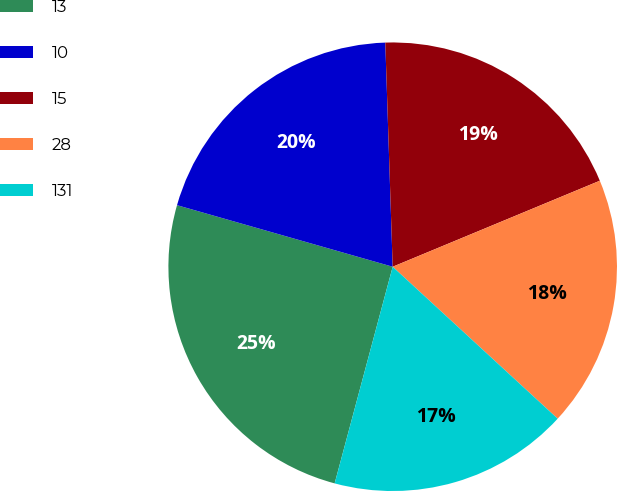Convert chart. <chart><loc_0><loc_0><loc_500><loc_500><pie_chart><fcel>13<fcel>10<fcel>15<fcel>28<fcel>131<nl><fcel>25.26%<fcel>20.05%<fcel>19.26%<fcel>18.11%<fcel>17.32%<nl></chart> 